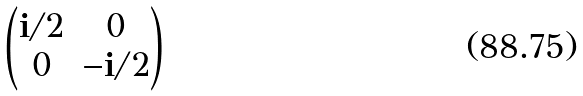Convert formula to latex. <formula><loc_0><loc_0><loc_500><loc_500>\begin{pmatrix} \mathbf i / 2 & 0 \\ 0 & - \mathbf i / 2 \end{pmatrix}</formula> 